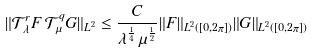Convert formula to latex. <formula><loc_0><loc_0><loc_500><loc_500>\| { \mathcal { T } } _ { \lambda } ^ { r } F \, { \mathcal { T } } _ { \mu } ^ { q } G \| _ { L ^ { 2 } } \leq \frac { C } { \lambda ^ { \frac { 1 } { 4 } } \, \mu ^ { \frac { 1 } { 2 } } } \| F \| _ { L ^ { 2 } ( [ 0 , 2 \pi ] ) } \| G \| _ { L ^ { 2 } ( [ 0 , 2 \pi ] ) }</formula> 